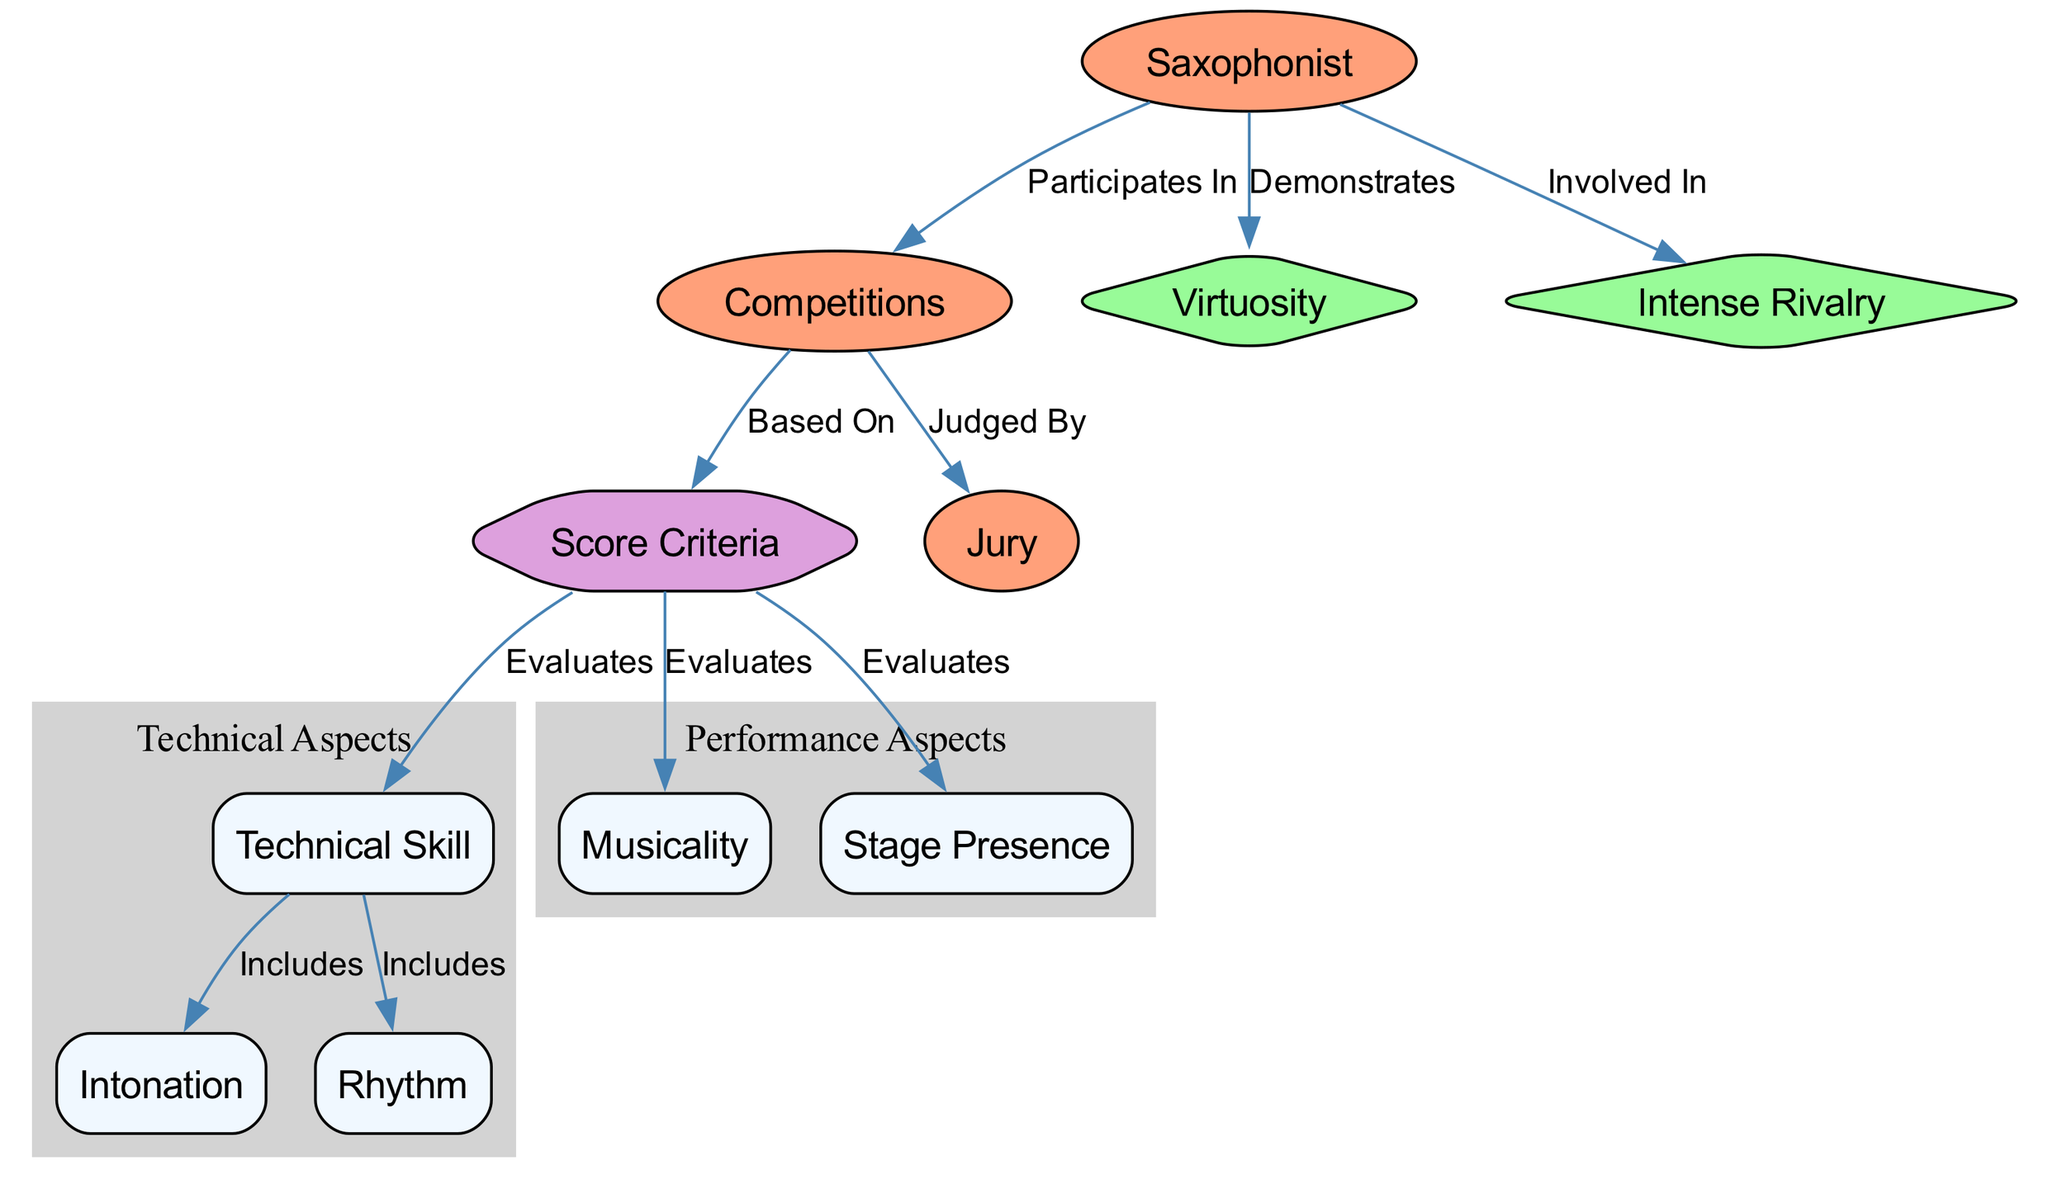What are the three main categories of score criteria? According to the diagram, the three main categories of score criteria are technical skill, musicality, and stage presence, as indicated by the edges connecting these nodes to the score criteria node.
Answer: technical skill, musicality, stage presence How many nodes represent performance aspects? The diagram represents two key performance aspects: musicality and stage presence. The relationship between these nodes and the score criteria supports this classification.
Answer: 2 Who judges the competitions? The jury judges the competitions, as indicated by the edge connecting the competitions node to the jury node, which clearly states that competitions are judged by the jury.
Answer: jury What two elements are included under technical skill? The technical skill node includes intonation and rhythm, as shown by the edges that link technical skill to these two elements, indicating they are components of technical skill.
Answer: intonation, rhythm How does a saxophonist demonstrate their abilities in competitions? The saxophonist demonstrates their abilities in competitions through their virtuosity and involvement in intense rivalry, as indicated by the connections between the saxophonist node and these two elements in the diagram.
Answer: virtuosity, intense rivalry What is the relationship between competitions and score criteria? Competitions are based on score criteria, as shown by the edge leading from the competitions node to the score criteria node, emphasizing that the score criteria are foundational for evaluating the competitions.
Answer: Based On How many edges connect to the score criteria? There are five edges connecting to the score criteria node, as seen in the diagram, indicating the various components that evaluate the score criteria.
Answer: 5 Which two criteria include the evaluation of technical skill? The technical skill node evaluates both intonation and rhythm, indicated by the edges linking from technical skill to these two criteria, establishing their inclusion in the broader category of technical skill.
Answer: intonation, rhythm Which aspect of evaluation includes musicality? The score criteria include the evaluation of musicality, as demonstrated by the direct link from score criteria to the musicality node in the diagram.
Answer: musicality 